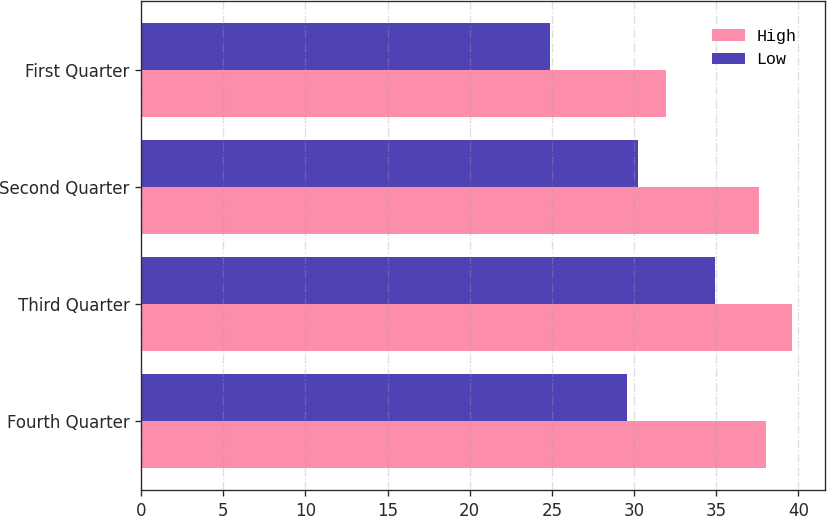<chart> <loc_0><loc_0><loc_500><loc_500><stacked_bar_chart><ecel><fcel>Fourth Quarter<fcel>Third Quarter<fcel>Second Quarter<fcel>First Quarter<nl><fcel>High<fcel>38.02<fcel>39.63<fcel>37.63<fcel>31.96<nl><fcel>Low<fcel>29.55<fcel>34.93<fcel>30.24<fcel>24.91<nl></chart> 